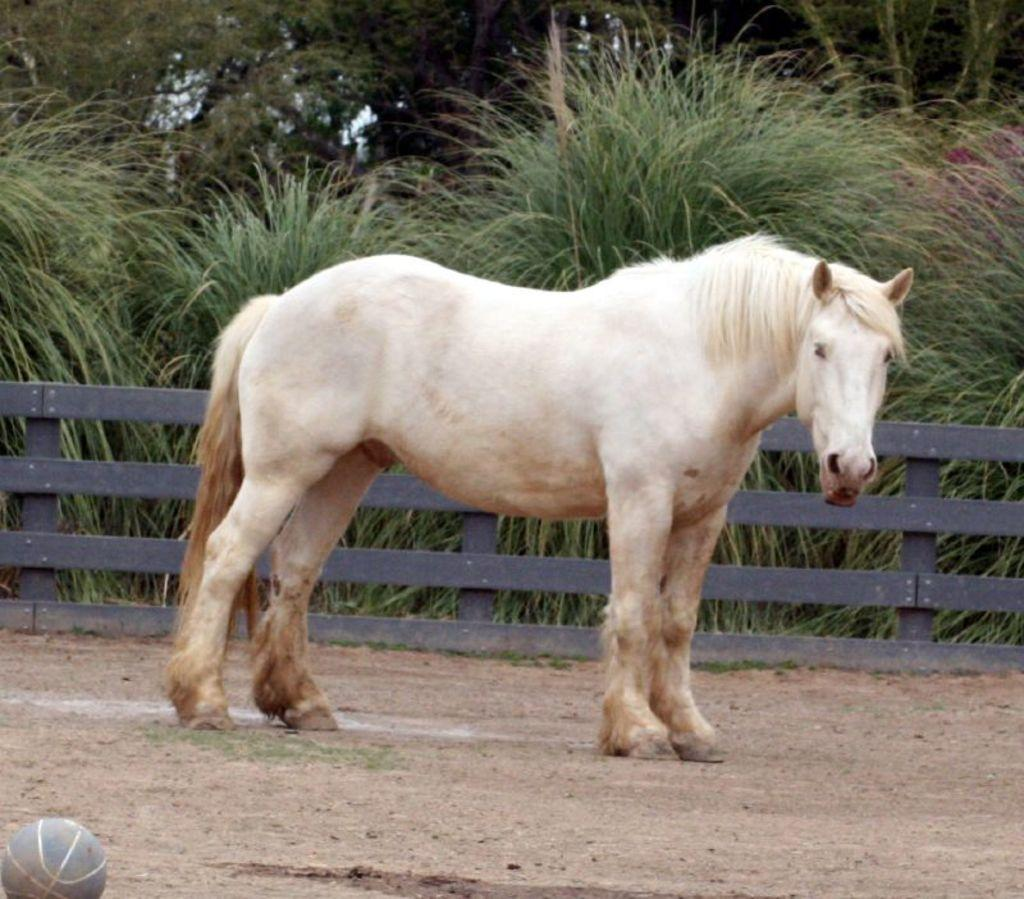What type of animal is in the image? There is a white horse in the image. Where is the horse located? The horse is standing on the ground. What can be seen in the background of the image? There is a fence, plants, and trees in the background of the image. What object is on the ground in the image? There is a ball on the ground in the image. What type of veil is draped over the horse in the image? There is no veil present in the image; the horse is not wearing any clothing or accessories. 